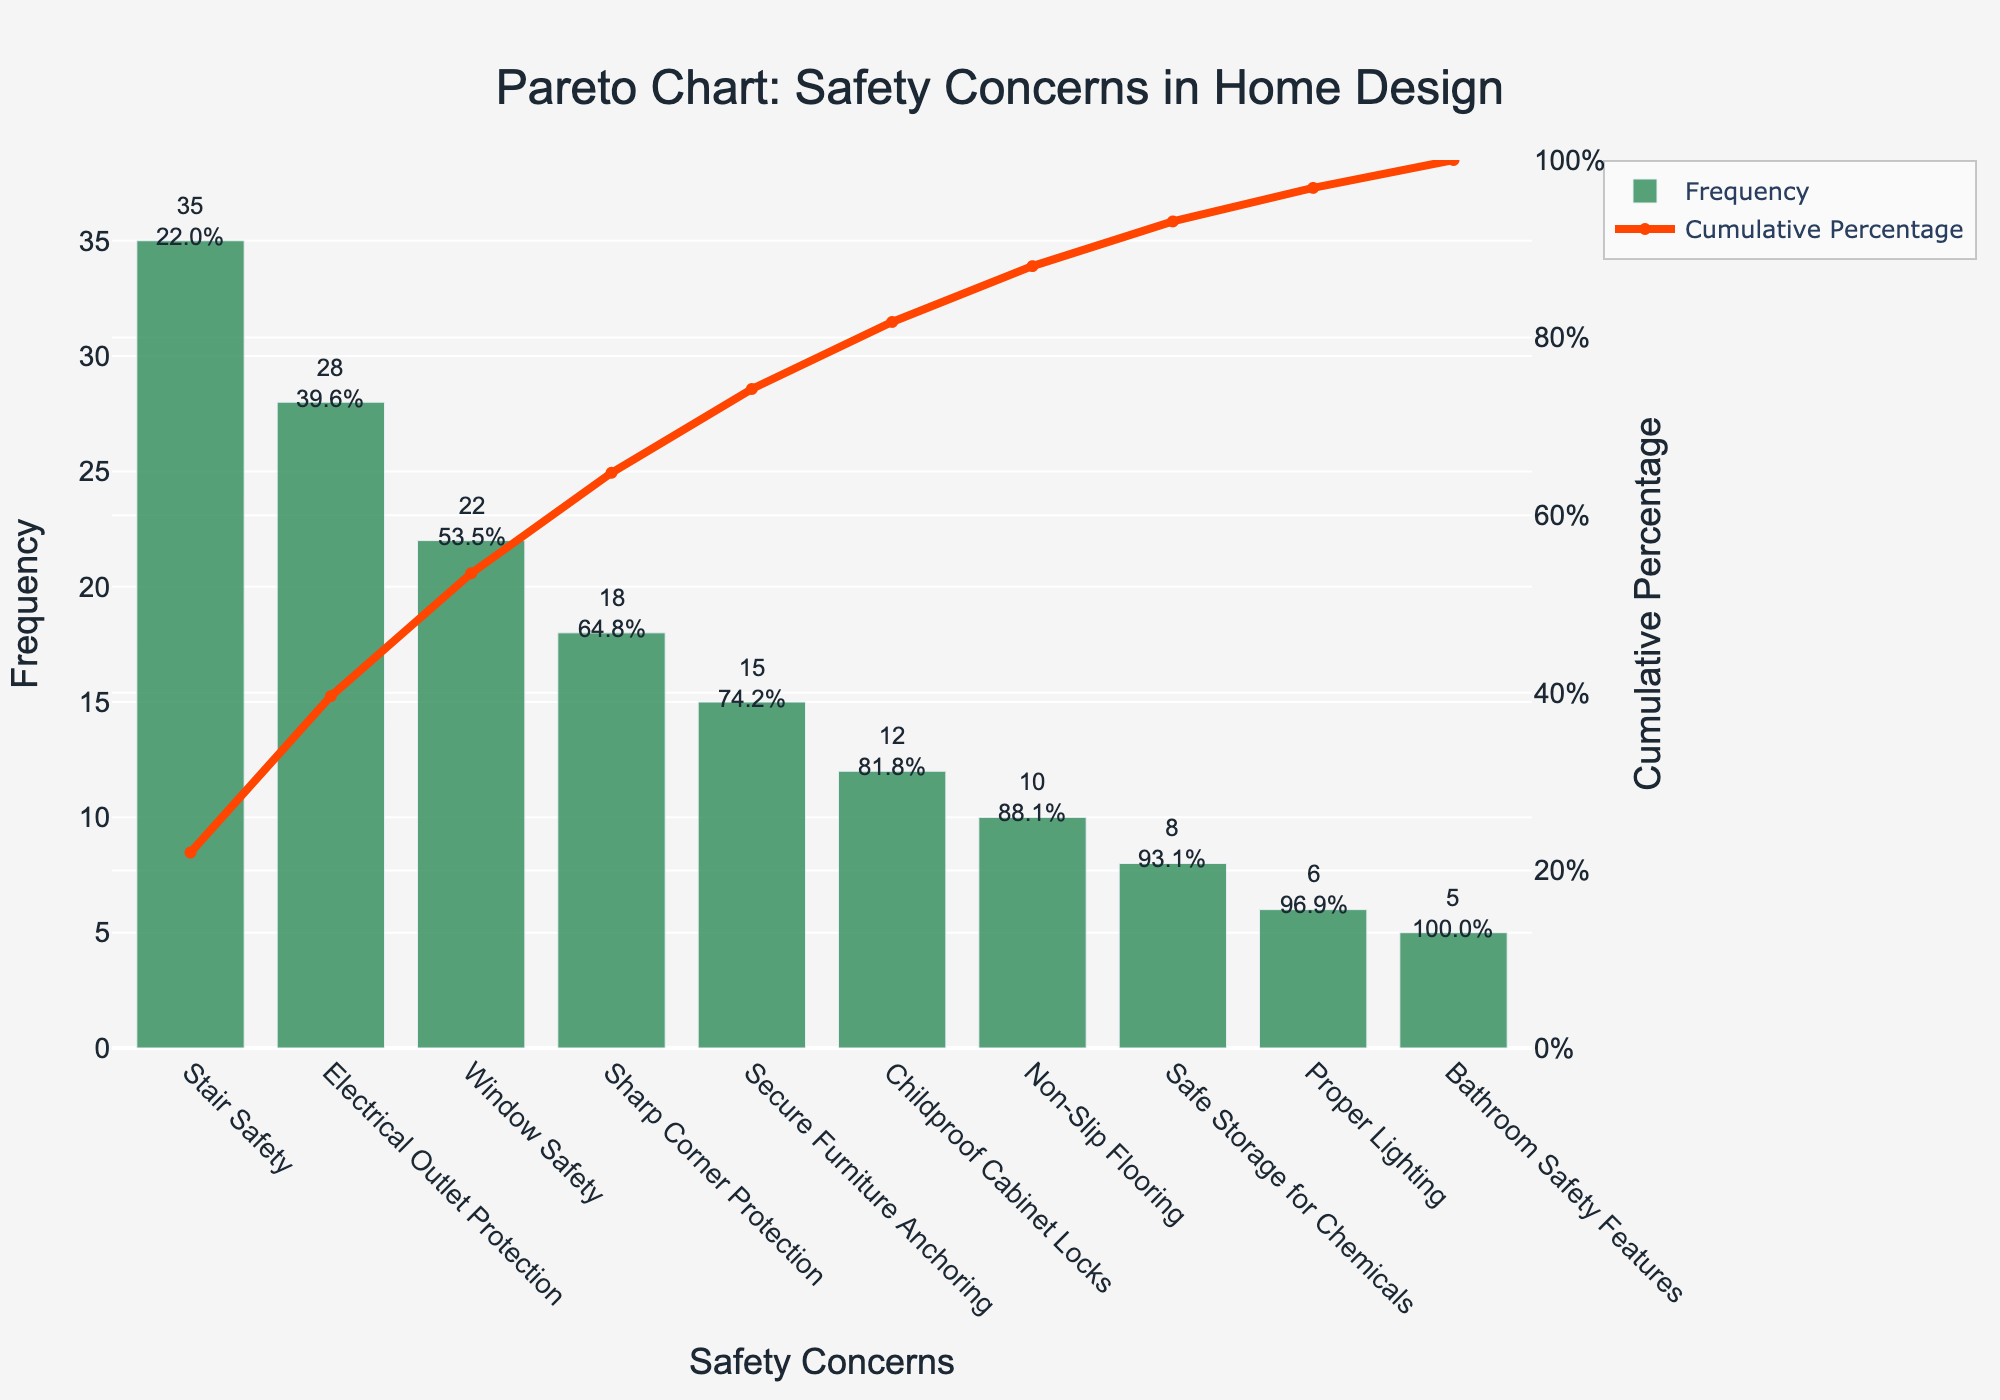What is the most frequent safety concern identified in the figure? The bar chart shows the frequency of various safety concerns. The tallest bar represents the most frequent concern.
Answer: Stair Safety What is the cumulative percentage for "Sharp Corner Protection"? Look at the line plot to find the cumulative percentage value aligned with "Sharp Corner Protection."
Answer: 79.4% Which safety concern has a lower frequency, "Childproof Cabinet Locks" or "Non-Slip Flooring"? Compare the height of the bars for "Childproof Cabinet Locks" and "Non-Slip Flooring" to determine which one is lower.
Answer: Non-Slip Flooring What is the cumulative percentage after "Secure Furniture Anchoring"? The line plot shows cumulative percentages, locate the point after "Secure Furniture Anchoring."
Answer: 83.2% How many safety concerns are listed in the figure? Count the number of bars in the bar chart.
Answer: 10 What percentage of concerns are accounted for by "Stair Safety" and "Electrical Outlet Protection" combined? Add the frequencies of "Stair Safety" and "Electrical Outlet Protection," then divide by the total frequency and multiply by 100.
Answer: 47.7% Which safety concern contributes to surpassing the 50% cumulative percentage threshold? Identify the safety concern from the line plot where the cumulative percentage first exceeds 50%.
Answer: Electrical Outlet Protection How many safety concerns have a frequency greater than 20? Count the bars with heights greater than 20 in the bar chart.
Answer: 3 What is the color of the bar representing "Bathroom Safety Features"? Identify the color of the bar corresponding to "Bathroom Safety Features."
Answer: Green By how much does the frequency of "Bathroom Safety Features" differ from "Stair Safety"? Subtract the frequency of "Bathroom Safety Features" from the frequency of "Stair Safety."
Answer: 30 